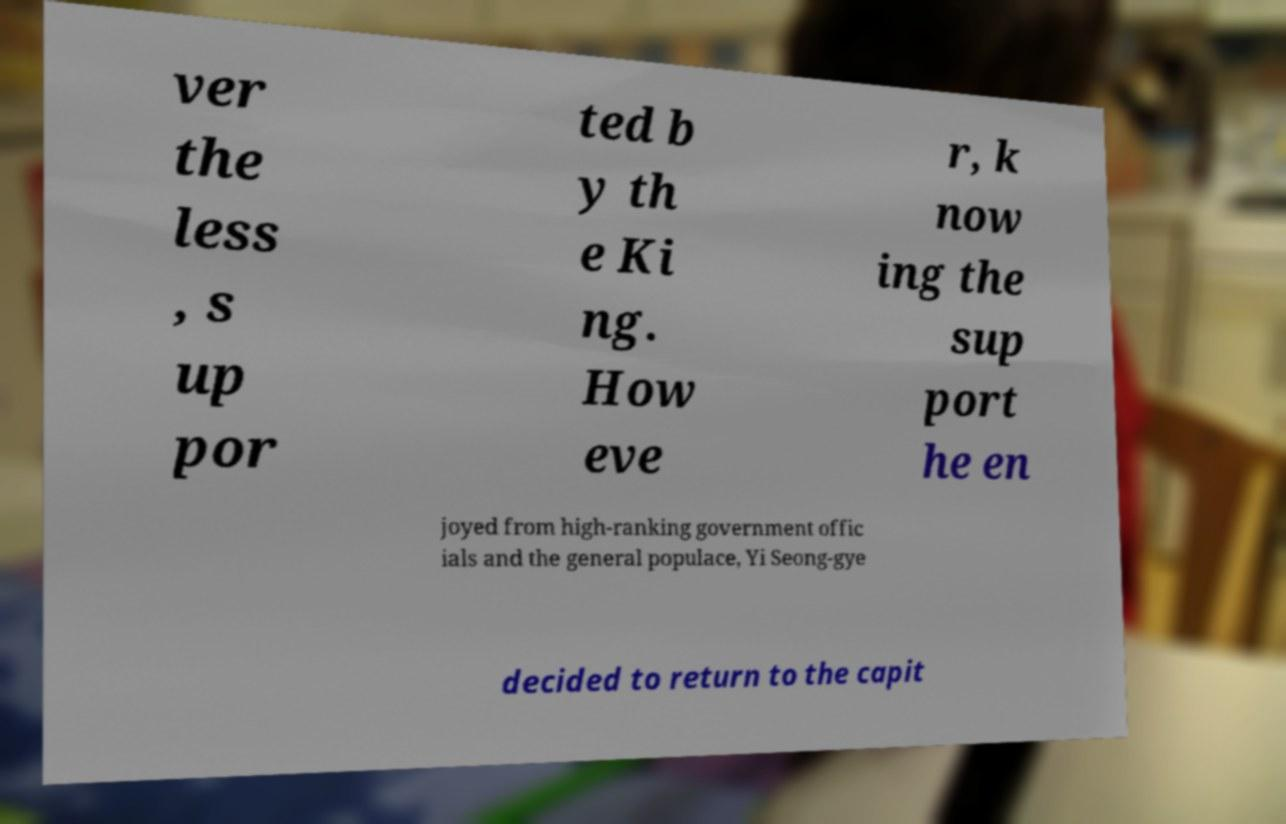I need the written content from this picture converted into text. Can you do that? ver the less , s up por ted b y th e Ki ng. How eve r, k now ing the sup port he en joyed from high-ranking government offic ials and the general populace, Yi Seong-gye decided to return to the capit 